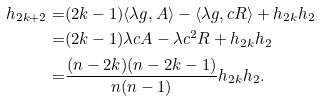Convert formula to latex. <formula><loc_0><loc_0><loc_500><loc_500>h _ { 2 k + 2 } = & ( 2 k - 1 ) \langle \lambda g , A \rangle - \langle \lambda g , c R \rangle + h _ { 2 k } h _ { 2 } \\ = & ( 2 k - 1 ) \lambda c A - \lambda c ^ { 2 } R + h _ { 2 k } h _ { 2 } \\ = & \frac { ( n - 2 k ) ( n - 2 k - 1 ) } { n ( n - 1 ) } h _ { 2 k } h _ { 2 } .</formula> 